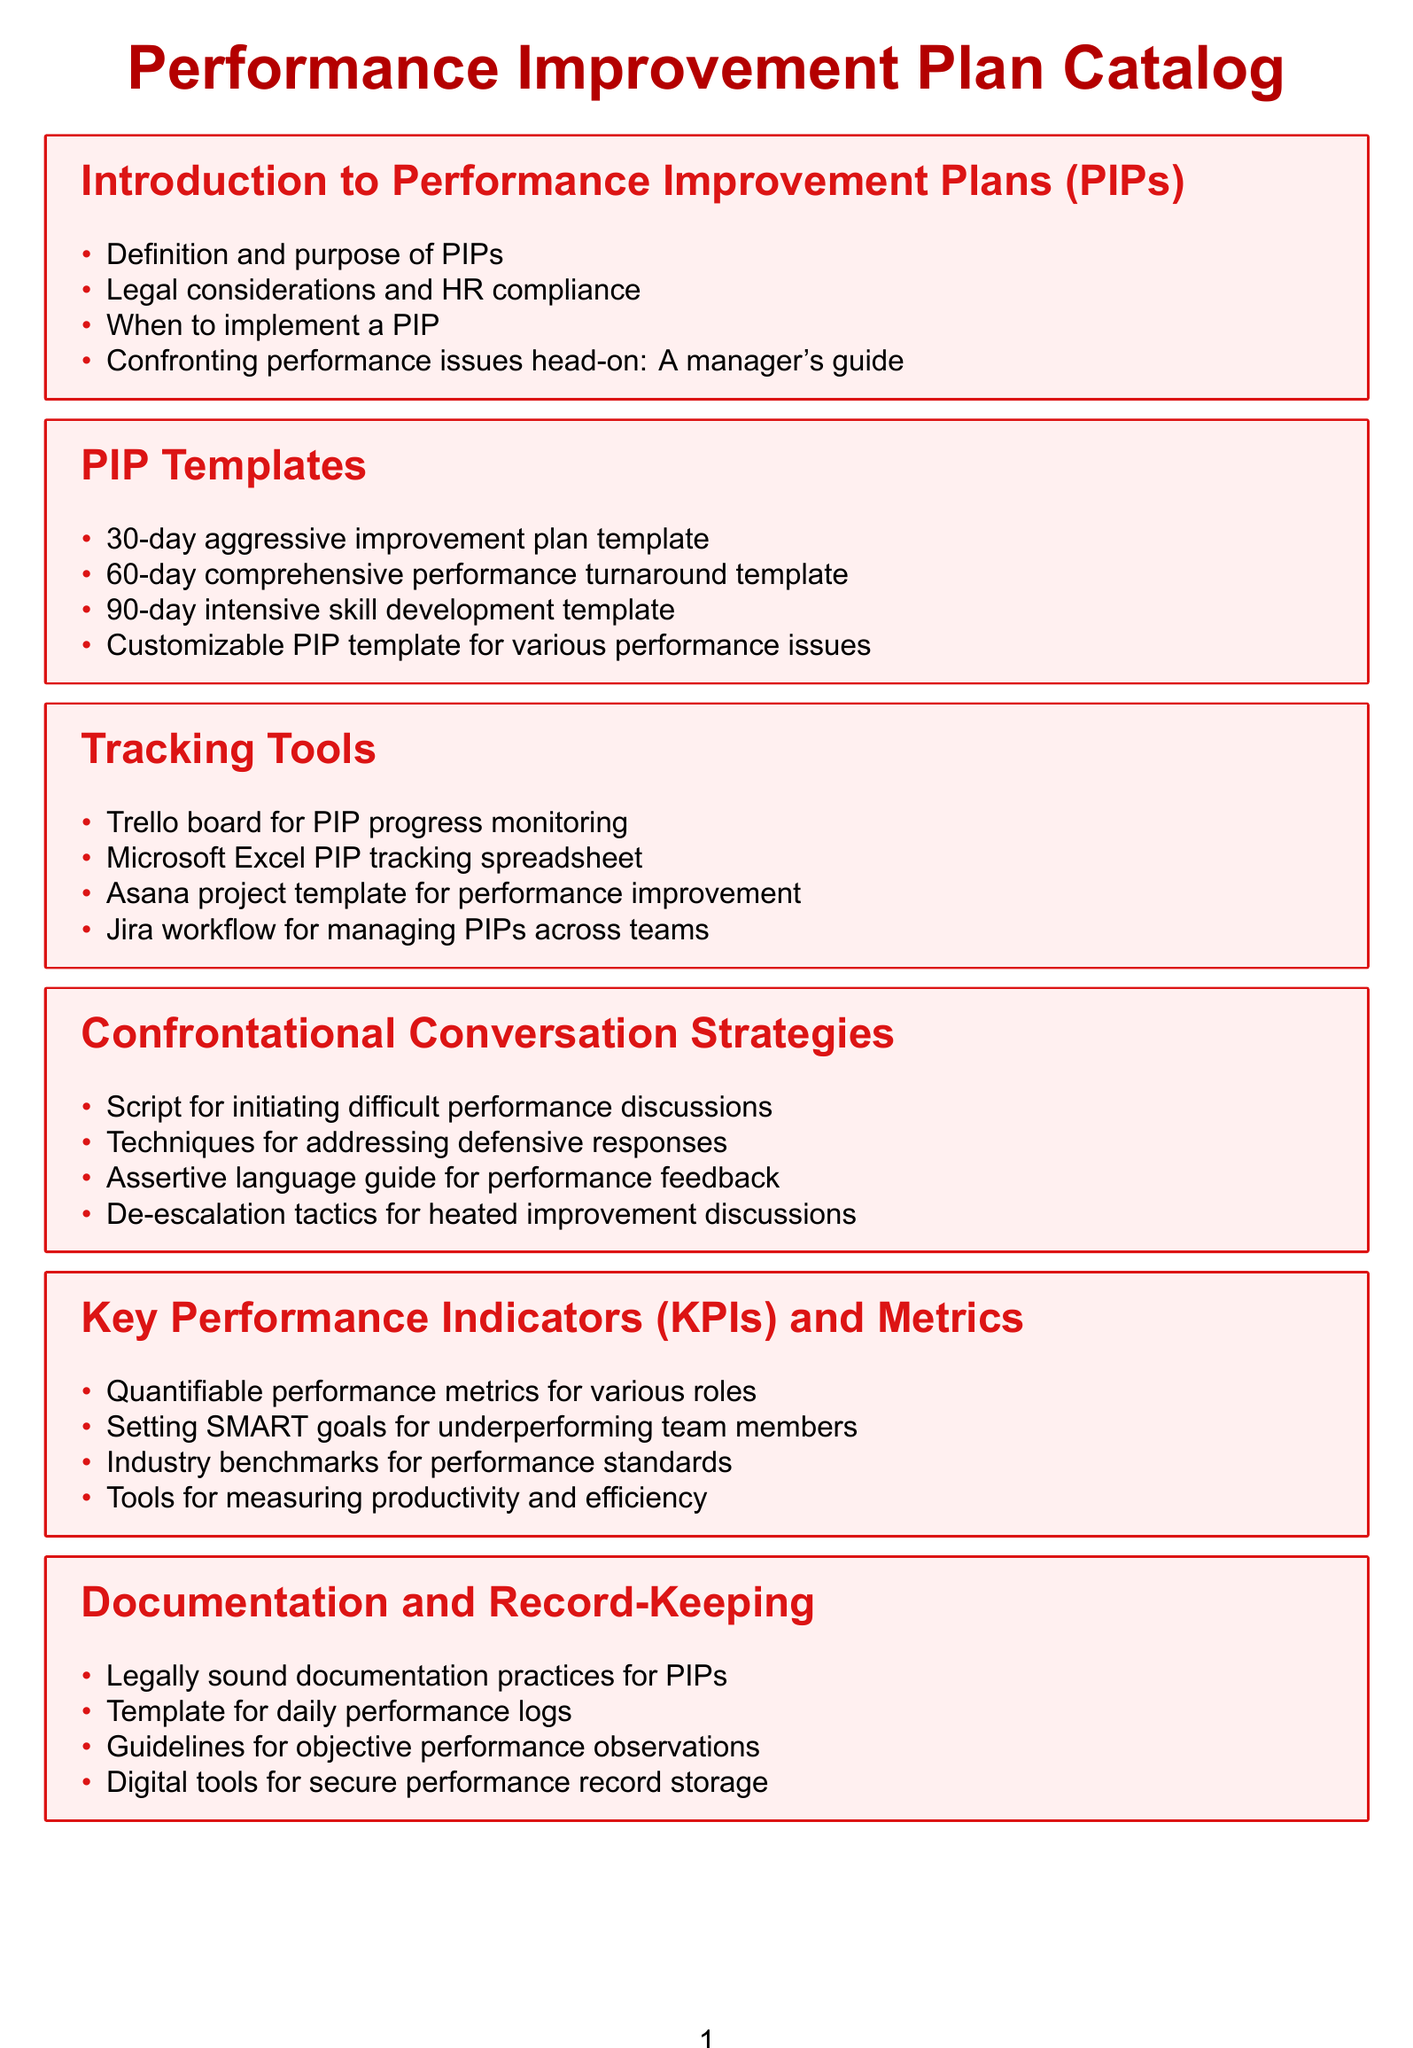What is the first section of the catalog? The first section is titled "Introduction to Performance Improvement Plans (PIPs)."
Answer: Introduction to Performance Improvement Plans (PIPs) How many types of PIP templates are listed? The document contains four types of PIP templates listed under the "PIP Templates" section.
Answer: 4 Name one tool for tracking PIP progress. The document lists several tools, and one example is a Trello board for PIP progress monitoring.
Answer: Trello board What are SMART goals intended for? SMART goals are intended for setting goals for underperforming team members.
Answer: Underperforming team members Which section includes strategies for confronting performance issues? The section that includes strategies for confronting performance issues is titled "Confrontational Conversation Strategies."
Answer: Confrontational Conversation Strategies What is the main purpose of the "PIP Outcome Management" section? The main purpose is to provide guidelines and frameworks for managing outcomes of performance improvement plans.
Answer: Guidelines and frameworks for managing outcomes What template can be customized for various performance issues? The document mentions a customizable PIP template for various performance issues.
Answer: Customizable PIP template What type of resource is Skillsoft mentioned as? Skillsoft is mentioned as a learning path for common performance issues.
Answer: Learning path for common performance issues How many sections are in the catalog? The document includes eight sections listed throughout.
Answer: 8 